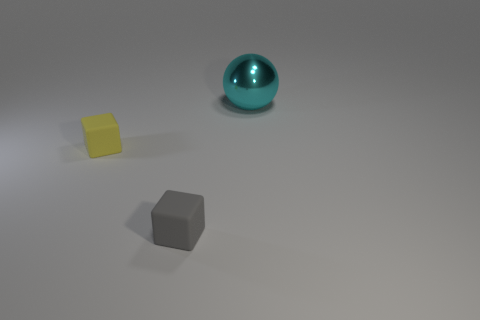What materials do the objects in the image appear to be made of? The objects in the image appear to be made of different materials. The sphere in the back seems to be metallic with a shiny surface, the gray cube looks to be matte, probably made of stone or a dull metal, and the smaller object which appears cube-like and yellowish, might be made of plastic or a similarly smooth material. 